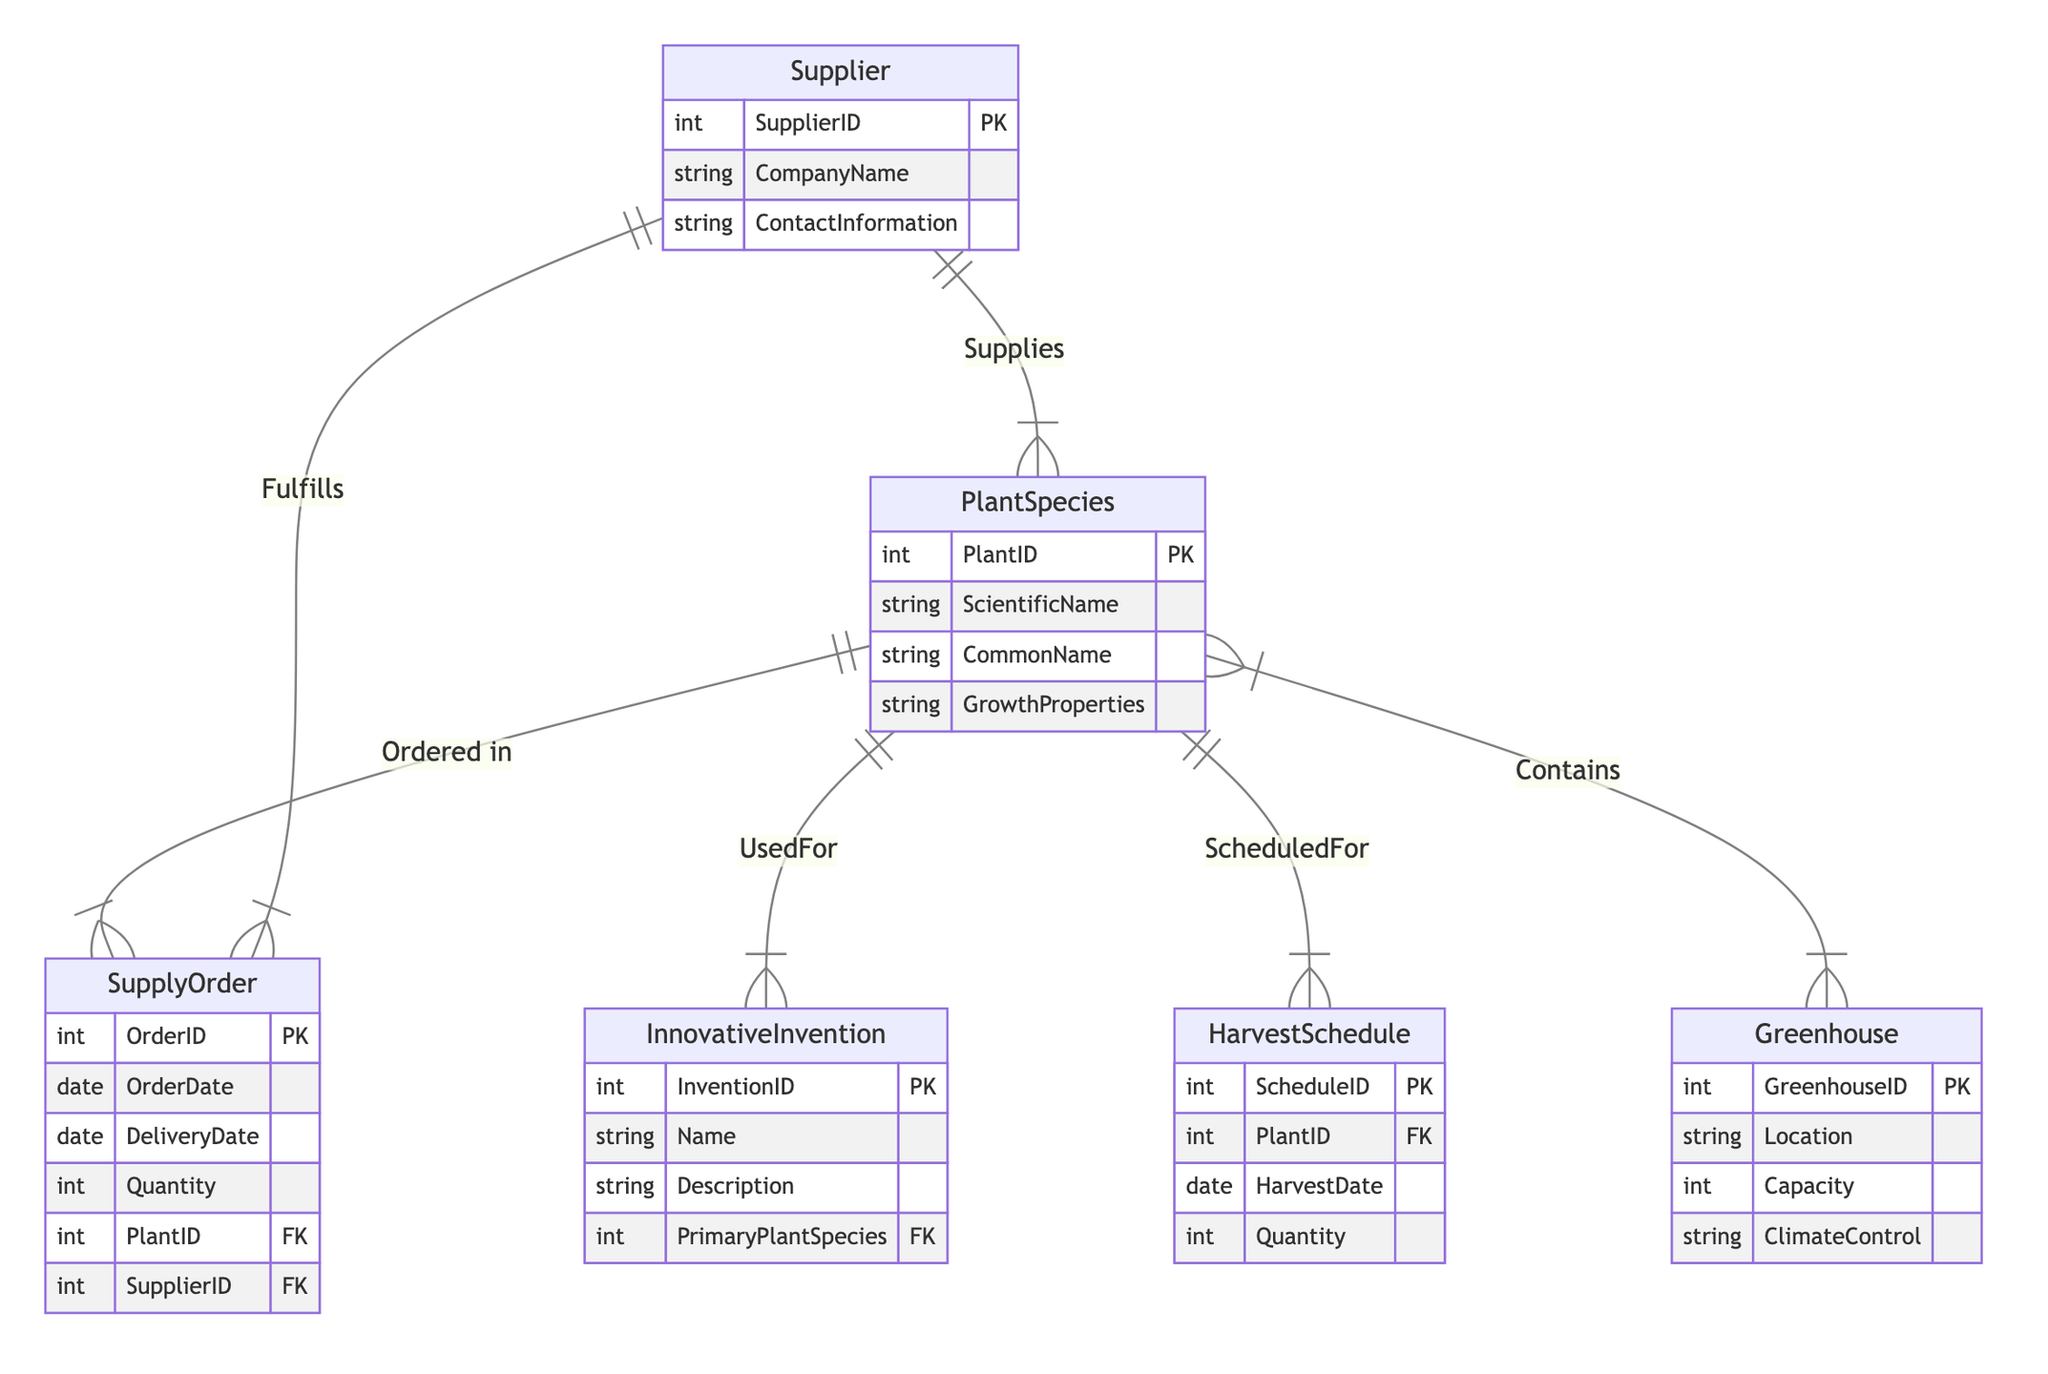What is the primary entity in the diagram? The primary entity in the diagram is "PlantSpecies," which serves as a central node connected to multiple other entities such as "InnovativeInvention," "SupplyOrder," "HarvestSchedule," and "Greenhouse."
Answer: PlantSpecies How many attributes does the "Supplier" entity have? The "Supplier" entity has three attributes: "SupplierID," "CompanyName," and "ContactInformation."
Answer: Three What relationship exists between "Supplier" and "PlantSpecies"? The relationship between "Supplier" and "PlantSpecies" is called "Supplies," indicating that suppliers provide certain plant species.
Answer: Supplies Which entity is used for the "HarvestSchedule"? The entity used for the "HarvestSchedule" is "PlantSpecies," as indicated by the relationship labeled "ScheduledFor," which connects these two entities.
Answer: PlantSpecies How many entities are listed in the diagram? There are six entities listed in the diagram: "PlantSpecies," "InnovativeInvention," "Supplier," "SupplyOrder," "HarvestSchedule," and "Greenhouse."
Answer: Six What is the purpose of the "Fulfills" relationship? The "Fulfills" relationship connects "SupplyOrder" to "Supplier," indicating that suppliers fulfill specific supply orders placed for plant species.
Answer: To indicate fulfillment of orders Which entity has a direct relationship with both "InnovativeInvention" and "HarvestSchedule"? The "PlantSpecies" entity has direct relationships with both "InnovativeInvention" through "UsedFor" and "HarvestSchedule" through "ScheduledFor."
Answer: PlantSpecies What is the attribute that connects "InnovativeInvention" to "PlantSpecies"? The attribute that connects these entities is "PrimaryPlantSpecies," which indicates the specific plant species used in the invention.
Answer: PrimaryPlantSpecies How many relationships are shown in the diagram? The diagram shows five relationships: "UsedFor," "ScheduledFor," "Supplies," "Contains," and "Fulfills."
Answer: Five 